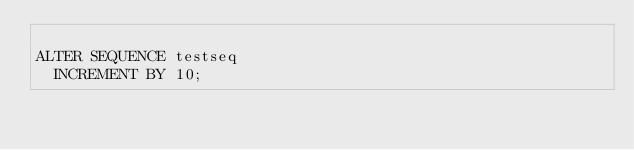<code> <loc_0><loc_0><loc_500><loc_500><_SQL_>
ALTER SEQUENCE testseq
	INCREMENT BY 10;
</code> 